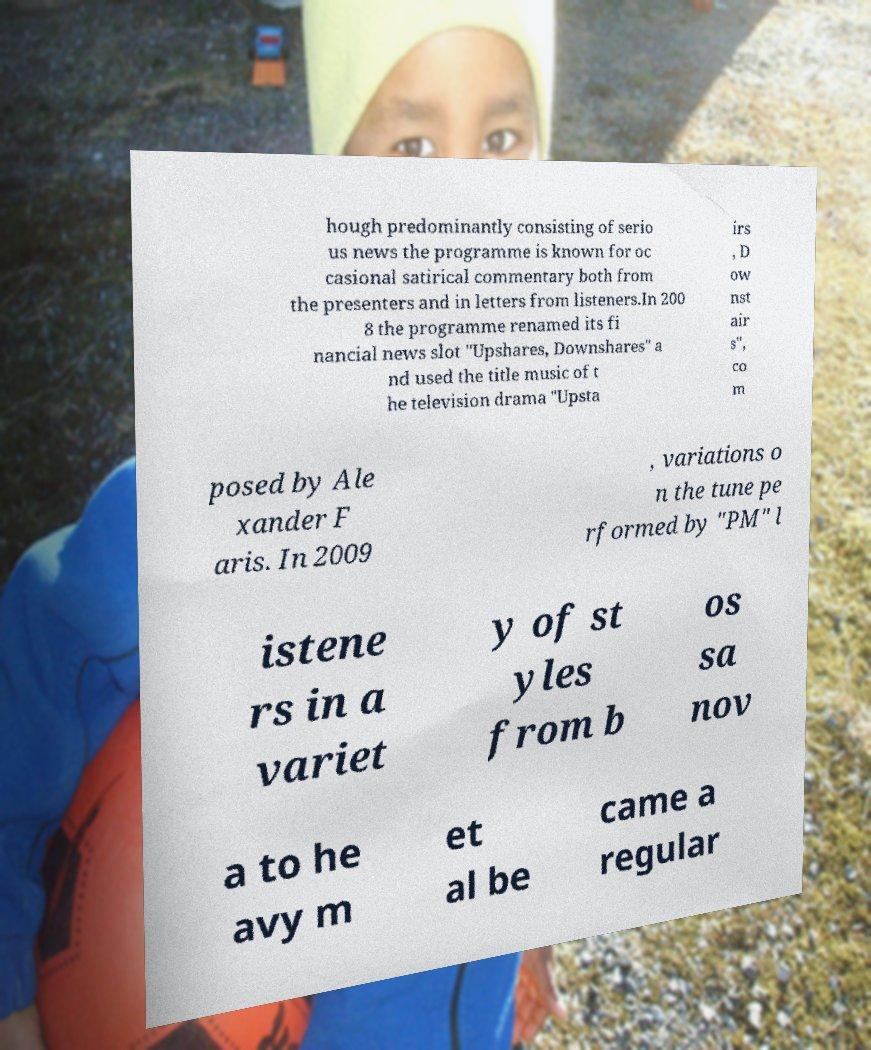I need the written content from this picture converted into text. Can you do that? hough predominantly consisting of serio us news the programme is known for oc casional satirical commentary both from the presenters and in letters from listeners.In 200 8 the programme renamed its fi nancial news slot "Upshares, Downshares" a nd used the title music of t he television drama "Upsta irs , D ow nst air s", co m posed by Ale xander F aris. In 2009 , variations o n the tune pe rformed by "PM" l istene rs in a variet y of st yles from b os sa nov a to he avy m et al be came a regular 